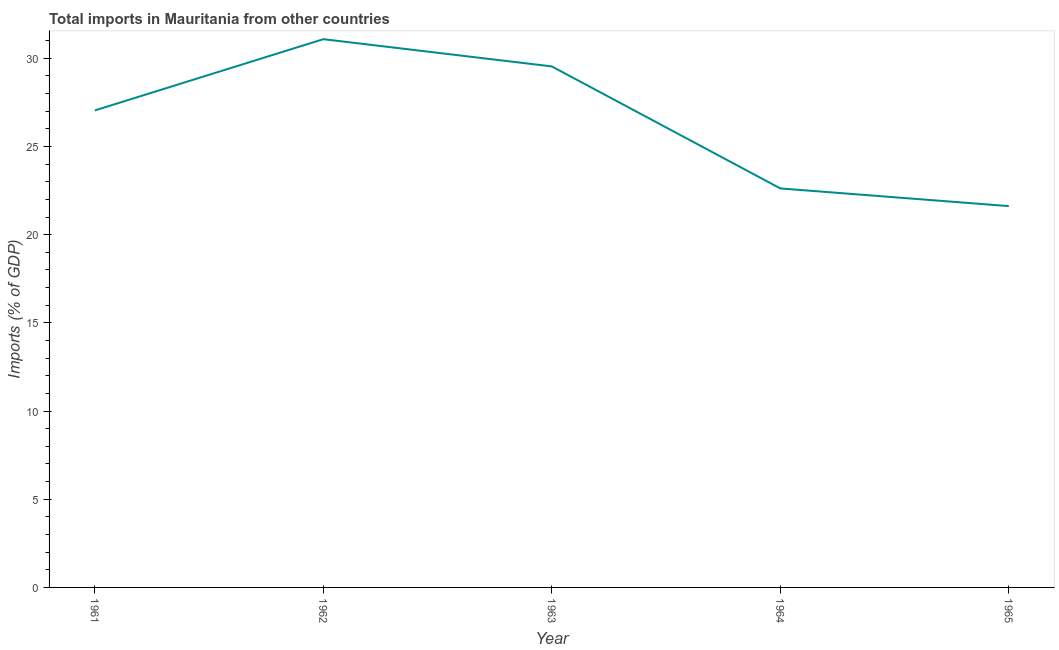What is the total imports in 1961?
Offer a terse response. 27.05. Across all years, what is the maximum total imports?
Your response must be concise. 31.09. Across all years, what is the minimum total imports?
Keep it short and to the point. 21.62. In which year was the total imports minimum?
Your response must be concise. 1965. What is the sum of the total imports?
Give a very brief answer. 131.92. What is the difference between the total imports in 1964 and 1965?
Offer a very short reply. 1. What is the average total imports per year?
Offer a very short reply. 26.38. What is the median total imports?
Offer a terse response. 27.05. In how many years, is the total imports greater than 29 %?
Make the answer very short. 2. What is the ratio of the total imports in 1963 to that in 1965?
Keep it short and to the point. 1.37. Is the difference between the total imports in 1962 and 1964 greater than the difference between any two years?
Your answer should be compact. No. What is the difference between the highest and the second highest total imports?
Your answer should be very brief. 1.54. What is the difference between the highest and the lowest total imports?
Offer a terse response. 9.47. In how many years, is the total imports greater than the average total imports taken over all years?
Provide a succinct answer. 3. Does the total imports monotonically increase over the years?
Your answer should be very brief. No. How many years are there in the graph?
Your response must be concise. 5. Are the values on the major ticks of Y-axis written in scientific E-notation?
Provide a succinct answer. No. Does the graph contain grids?
Ensure brevity in your answer.  No. What is the title of the graph?
Keep it short and to the point. Total imports in Mauritania from other countries. What is the label or title of the Y-axis?
Provide a short and direct response. Imports (% of GDP). What is the Imports (% of GDP) in 1961?
Your response must be concise. 27.05. What is the Imports (% of GDP) of 1962?
Your answer should be compact. 31.09. What is the Imports (% of GDP) of 1963?
Make the answer very short. 29.54. What is the Imports (% of GDP) of 1964?
Your response must be concise. 22.62. What is the Imports (% of GDP) of 1965?
Give a very brief answer. 21.62. What is the difference between the Imports (% of GDP) in 1961 and 1962?
Your response must be concise. -4.04. What is the difference between the Imports (% of GDP) in 1961 and 1963?
Your answer should be very brief. -2.5. What is the difference between the Imports (% of GDP) in 1961 and 1964?
Ensure brevity in your answer.  4.42. What is the difference between the Imports (% of GDP) in 1961 and 1965?
Your answer should be very brief. 5.43. What is the difference between the Imports (% of GDP) in 1962 and 1963?
Provide a succinct answer. 1.54. What is the difference between the Imports (% of GDP) in 1962 and 1964?
Keep it short and to the point. 8.46. What is the difference between the Imports (% of GDP) in 1962 and 1965?
Provide a short and direct response. 9.47. What is the difference between the Imports (% of GDP) in 1963 and 1964?
Provide a succinct answer. 6.92. What is the difference between the Imports (% of GDP) in 1963 and 1965?
Ensure brevity in your answer.  7.92. What is the difference between the Imports (% of GDP) in 1964 and 1965?
Offer a terse response. 1. What is the ratio of the Imports (% of GDP) in 1961 to that in 1962?
Your answer should be very brief. 0.87. What is the ratio of the Imports (% of GDP) in 1961 to that in 1963?
Make the answer very short. 0.92. What is the ratio of the Imports (% of GDP) in 1961 to that in 1964?
Ensure brevity in your answer.  1.2. What is the ratio of the Imports (% of GDP) in 1961 to that in 1965?
Provide a short and direct response. 1.25. What is the ratio of the Imports (% of GDP) in 1962 to that in 1963?
Offer a very short reply. 1.05. What is the ratio of the Imports (% of GDP) in 1962 to that in 1964?
Provide a succinct answer. 1.37. What is the ratio of the Imports (% of GDP) in 1962 to that in 1965?
Your answer should be compact. 1.44. What is the ratio of the Imports (% of GDP) in 1963 to that in 1964?
Give a very brief answer. 1.31. What is the ratio of the Imports (% of GDP) in 1963 to that in 1965?
Offer a very short reply. 1.37. What is the ratio of the Imports (% of GDP) in 1964 to that in 1965?
Your answer should be very brief. 1.05. 